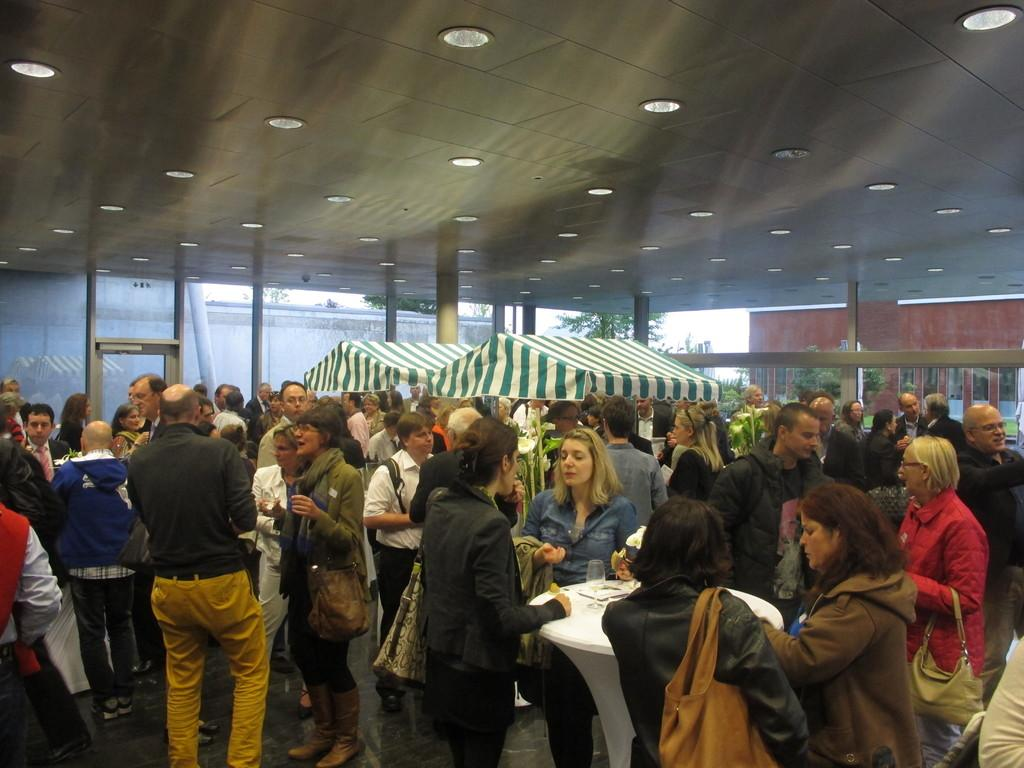How many people are present in the image? There are many people in the image. What type of furniture can be seen in the image? There are tables in the image. What type of temporary shelter is present in the image? There are tents in the image. What can be seen in the background of the image? There are trees in the background of the image. What is visible at the top of the image? There are lights visible at the top of the image. What color is the eye of the person in the image? There is no eye visible in the image, as it features many people, tables, tents, trees, and lights, but no specific person's eye is mentioned in the facts. 